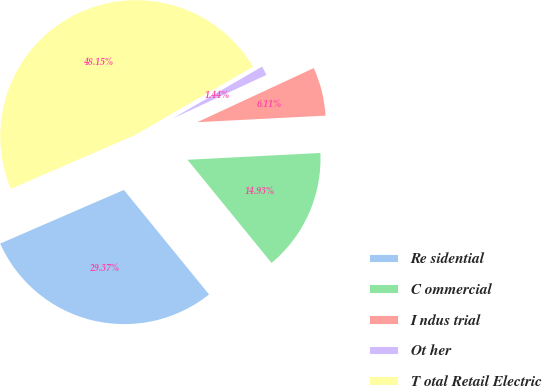Convert chart to OTSL. <chart><loc_0><loc_0><loc_500><loc_500><pie_chart><fcel>Re sidential<fcel>C ommercial<fcel>I ndus trial<fcel>Ot her<fcel>T otal Retail Electric<nl><fcel>29.37%<fcel>14.93%<fcel>6.11%<fcel>1.44%<fcel>48.15%<nl></chart> 